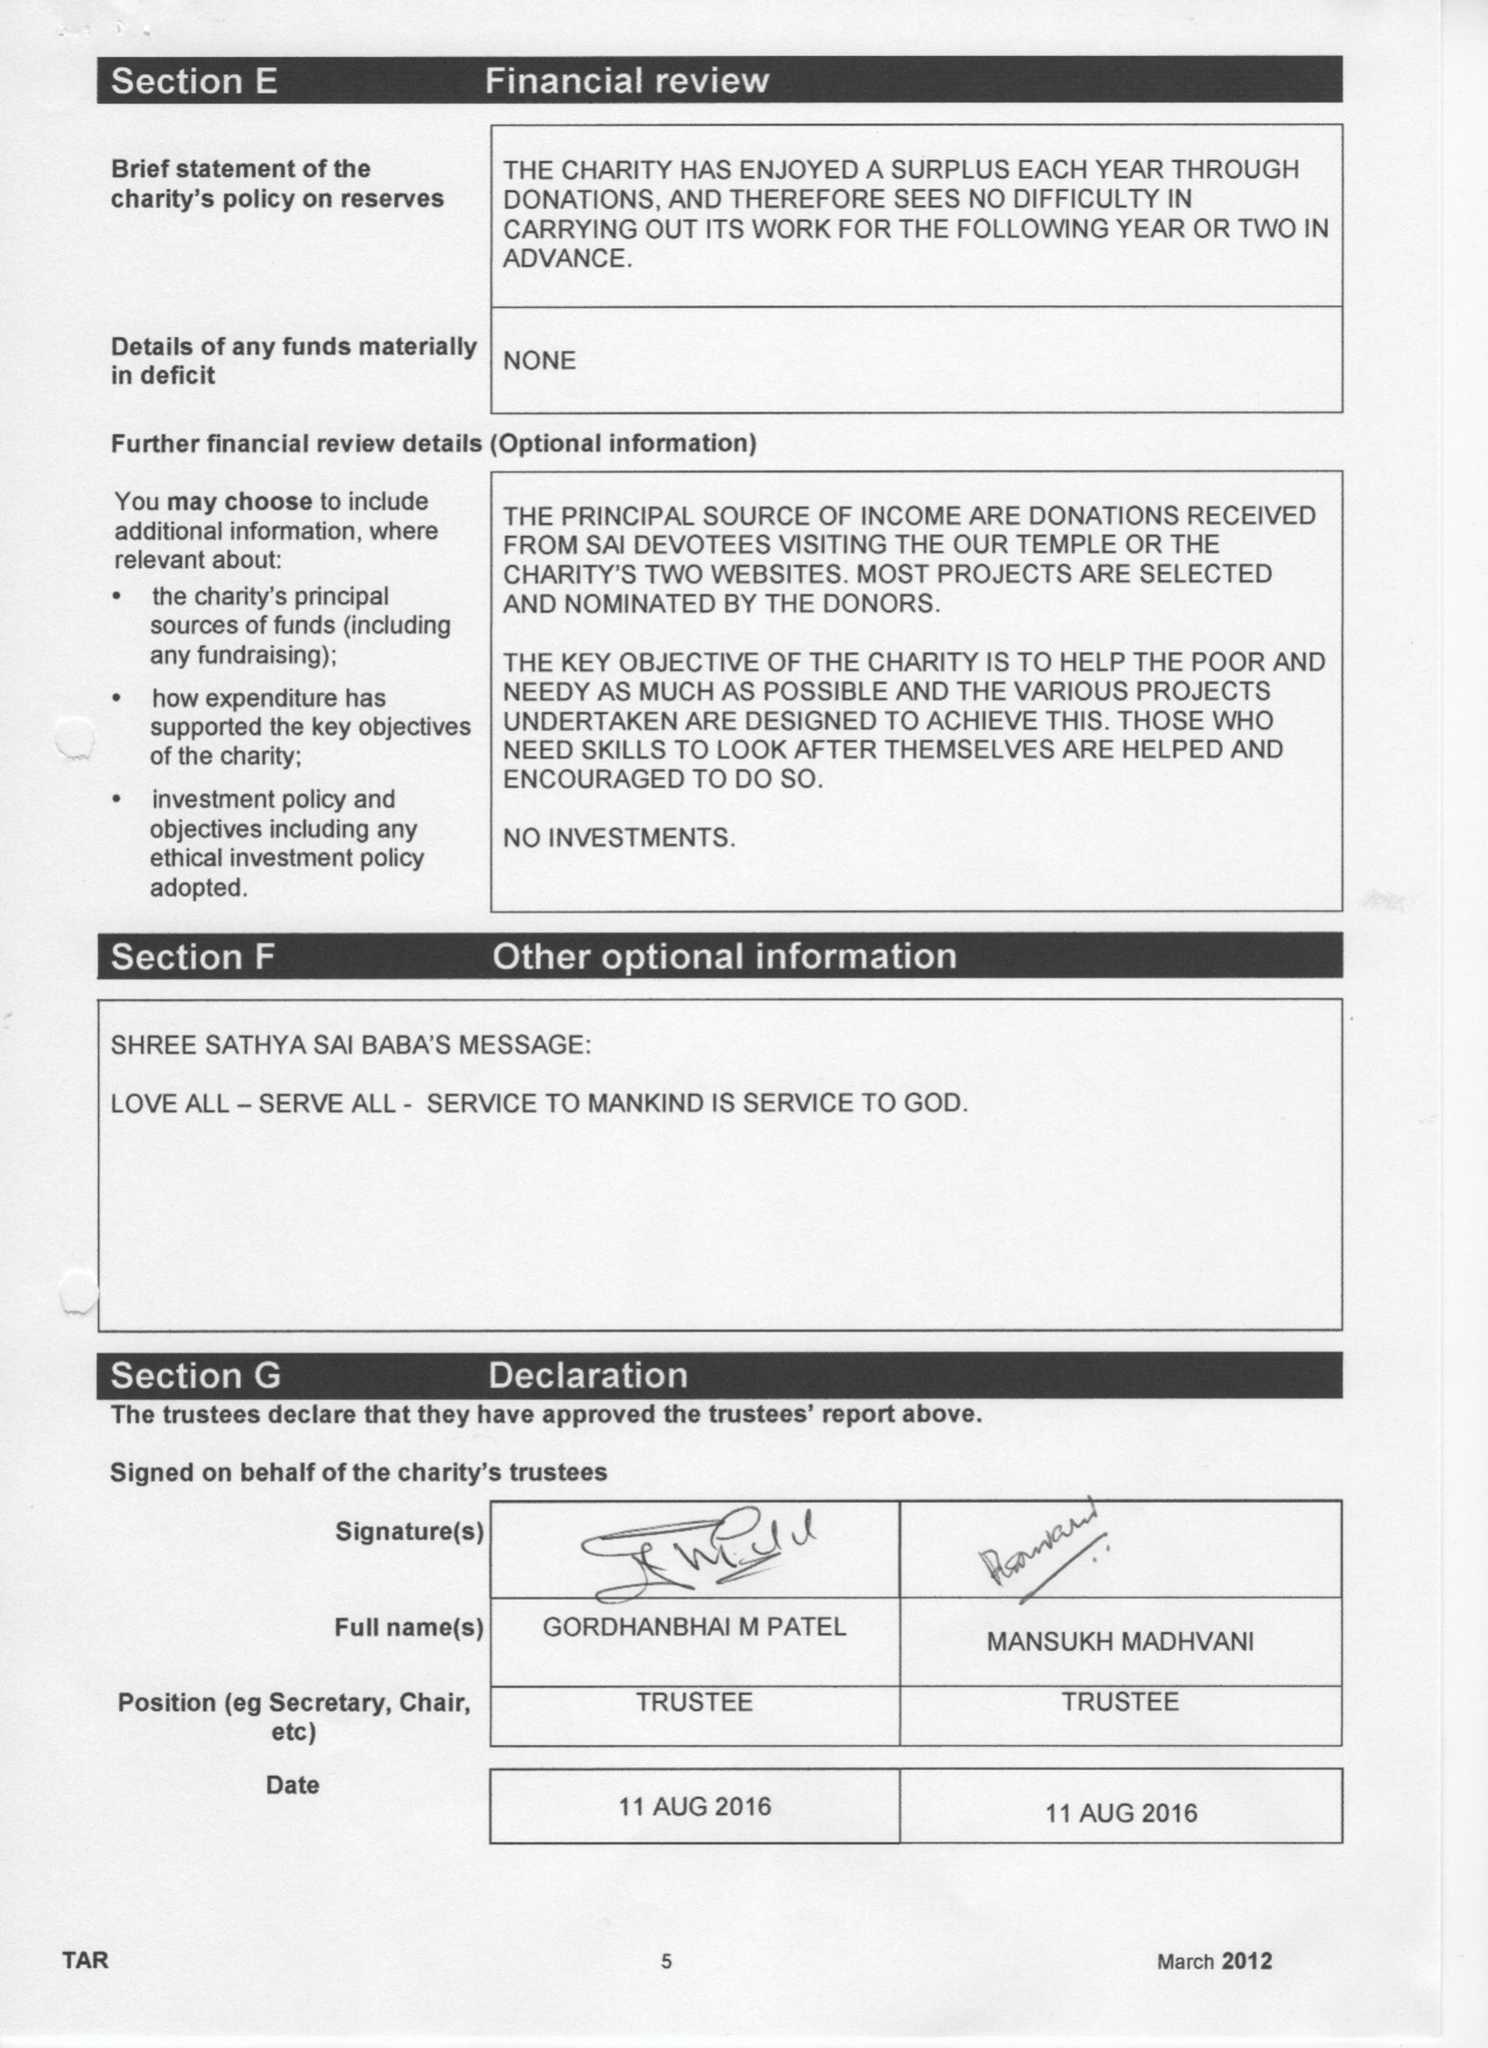What is the value for the address__postcode?
Answer the question using a single word or phrase. HA3 7EJ 